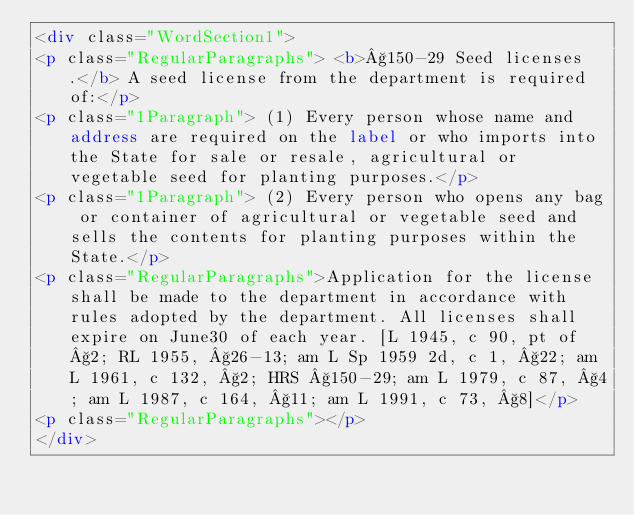<code> <loc_0><loc_0><loc_500><loc_500><_HTML_><div class="WordSection1">
<p class="RegularParagraphs"> <b>§150-29 Seed licenses.</b> A seed license from the department is required of:</p>
<p class="1Paragraph"> (1) Every person whose name and address are required on the label or who imports into the State for sale or resale, agricultural or vegetable seed for planting purposes.</p>
<p class="1Paragraph"> (2) Every person who opens any bag or container of agricultural or vegetable seed and sells the contents for planting purposes within the State.</p>
<p class="RegularParagraphs">Application for the license shall be made to the department in accordance with rules adopted by the department. All licenses shall expire on June30 of each year. [L 1945, c 90, pt of §2; RL 1955, §26-13; am L Sp 1959 2d, c 1, §22; am L 1961, c 132, §2; HRS §150-29; am L 1979, c 87, §4; am L 1987, c 164, §11; am L 1991, c 73, §8]</p>
<p class="RegularParagraphs"></p>
</div></code> 